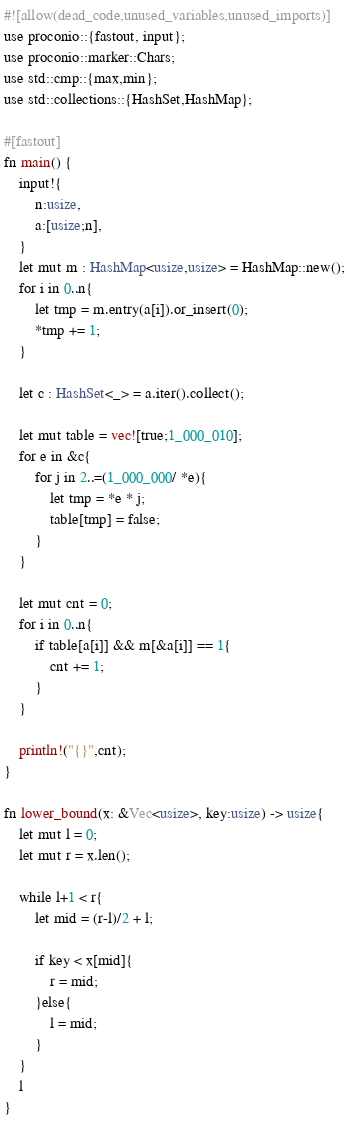Convert code to text. <code><loc_0><loc_0><loc_500><loc_500><_Rust_>#![allow(dead_code,unused_variables,unused_imports)]
use proconio::{fastout, input};
use proconio::marker::Chars;
use std::cmp::{max,min};
use std::collections::{HashSet,HashMap};

#[fastout]
fn main() {
    input!{
        n:usize,
        a:[usize;n],
    }
    let mut m : HashMap<usize,usize> = HashMap::new();
    for i in 0..n{
        let tmp = m.entry(a[i]).or_insert(0);
        *tmp += 1;
    }

    let c : HashSet<_> = a.iter().collect();

    let mut table = vec![true;1_000_010];
    for e in &c{
        for j in 2..=(1_000_000/ *e){
            let tmp = *e * j;
            table[tmp] = false;
        }
    }

    let mut cnt = 0;
    for i in 0..n{
        if table[a[i]] && m[&a[i]] == 1{
            cnt += 1;
        }
    }
    
    println!("{}",cnt);
}

fn lower_bound(x: &Vec<usize>, key:usize) -> usize{
    let mut l = 0;
    let mut r = x.len();

    while l+1 < r{
        let mid = (r-l)/2 + l;

        if key < x[mid]{
            r = mid;
        }else{
            l = mid;
        }
    }
    l
}</code> 